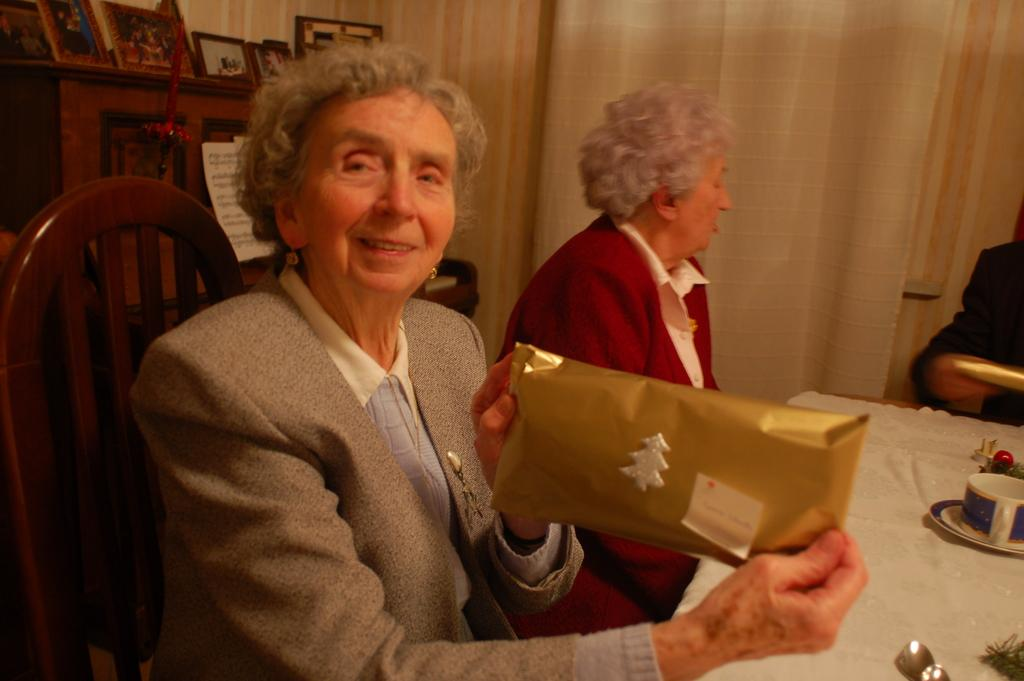What is the woman in the image doing? The woman is sitting and smiling in the image. What is the woman holding or showing? The woman is holding or showing a gift pack. Who is beside the woman? There is another woman beside her. What is the second woman doing? The second woman is speaking to someone else. What type of badge does the family member have in the image? There is no mention of a family member or a badge in the image. 